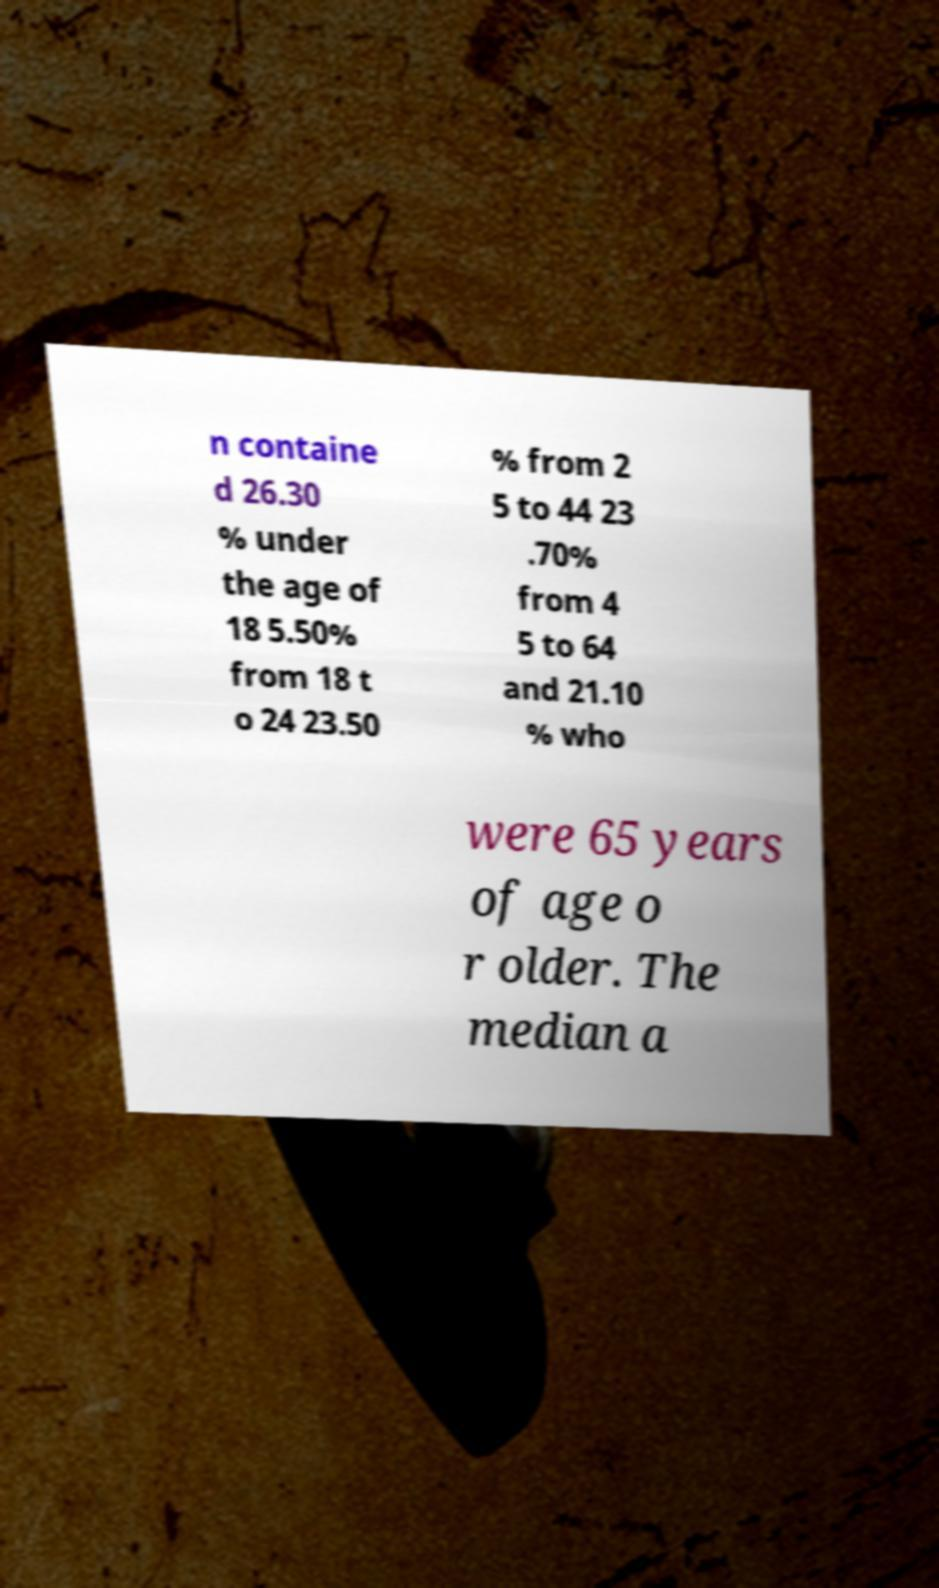What messages or text are displayed in this image? I need them in a readable, typed format. n containe d 26.30 % under the age of 18 5.50% from 18 t o 24 23.50 % from 2 5 to 44 23 .70% from 4 5 to 64 and 21.10 % who were 65 years of age o r older. The median a 